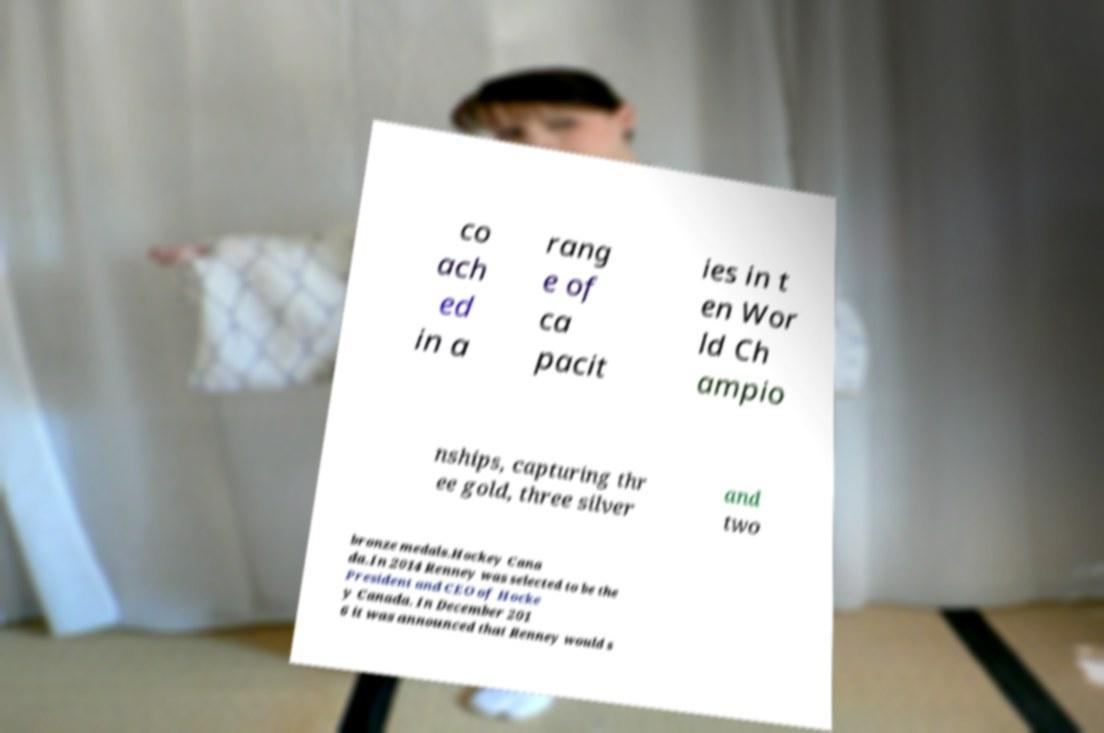Can you accurately transcribe the text from the provided image for me? co ach ed in a rang e of ca pacit ies in t en Wor ld Ch ampio nships, capturing thr ee gold, three silver and two bronze medals.Hockey Cana da.In 2014 Renney was selected to be the President and CEO of Hocke y Canada. In December 201 6 it was announced that Renney would s 